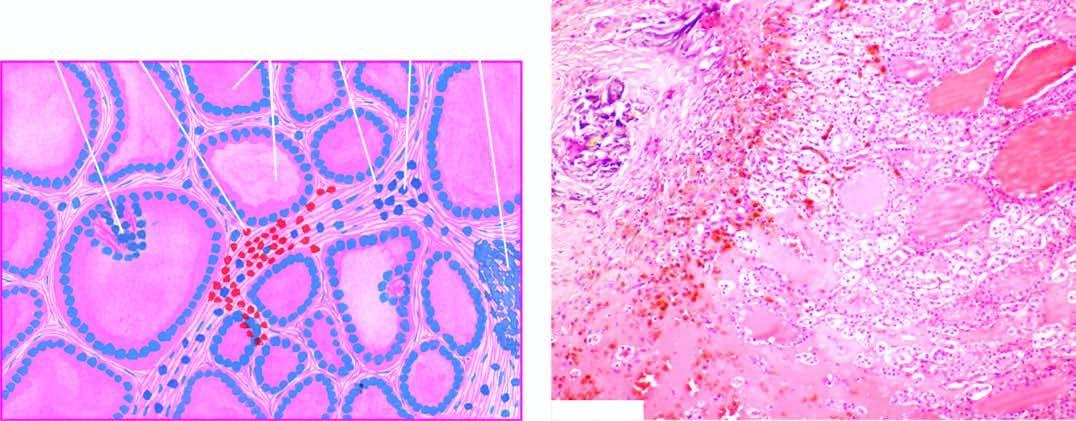re characteristic features: nodularity, extensive scarring with foci of calcification, areas of haemorrhages and variable-sized follicles lined by flat to high epithelium and containing abundant colloid?
Answer the question using a single word or phrase. No 